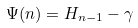<formula> <loc_0><loc_0><loc_500><loc_500>\Psi ( n ) = H _ { n - 1 } - \gamma</formula> 